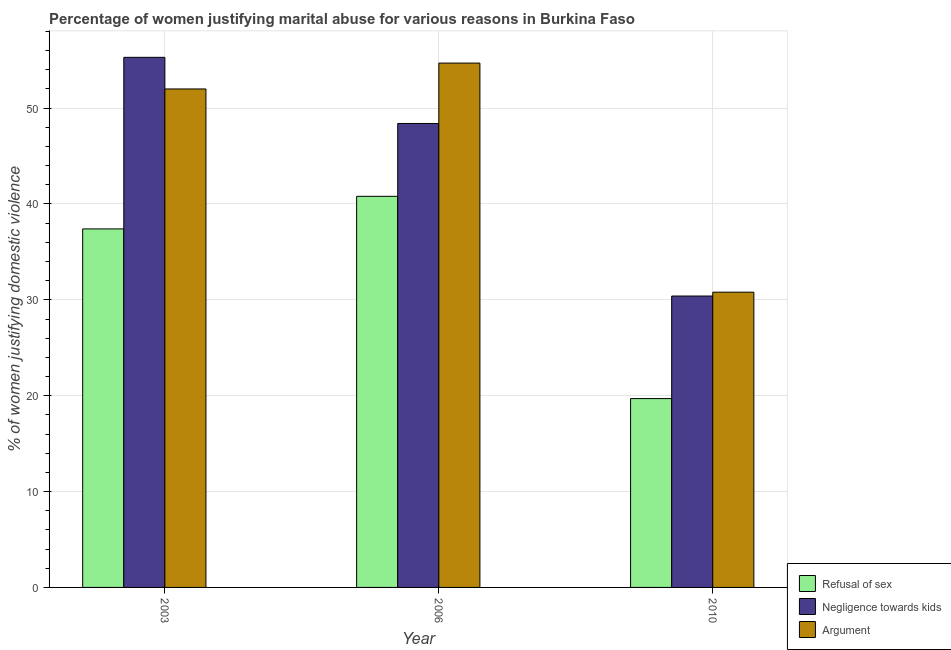How many different coloured bars are there?
Your response must be concise. 3. How many groups of bars are there?
Give a very brief answer. 3. What is the label of the 2nd group of bars from the left?
Make the answer very short. 2006. In how many cases, is the number of bars for a given year not equal to the number of legend labels?
Offer a terse response. 0. What is the percentage of women justifying domestic violence due to negligence towards kids in 2003?
Offer a terse response. 55.3. Across all years, what is the maximum percentage of women justifying domestic violence due to negligence towards kids?
Provide a short and direct response. 55.3. Across all years, what is the minimum percentage of women justifying domestic violence due to arguments?
Provide a short and direct response. 30.8. In which year was the percentage of women justifying domestic violence due to refusal of sex minimum?
Offer a very short reply. 2010. What is the total percentage of women justifying domestic violence due to arguments in the graph?
Offer a very short reply. 137.5. What is the difference between the percentage of women justifying domestic violence due to refusal of sex in 2010 and the percentage of women justifying domestic violence due to negligence towards kids in 2006?
Offer a very short reply. -21.1. What is the average percentage of women justifying domestic violence due to negligence towards kids per year?
Give a very brief answer. 44.7. In the year 2010, what is the difference between the percentage of women justifying domestic violence due to arguments and percentage of women justifying domestic violence due to negligence towards kids?
Ensure brevity in your answer.  0. In how many years, is the percentage of women justifying domestic violence due to negligence towards kids greater than 54 %?
Your answer should be compact. 1. What is the ratio of the percentage of women justifying domestic violence due to arguments in 2003 to that in 2006?
Your response must be concise. 0.95. Is the percentage of women justifying domestic violence due to arguments in 2003 less than that in 2006?
Offer a very short reply. Yes. Is the difference between the percentage of women justifying domestic violence due to arguments in 2003 and 2006 greater than the difference between the percentage of women justifying domestic violence due to refusal of sex in 2003 and 2006?
Give a very brief answer. No. What is the difference between the highest and the second highest percentage of women justifying domestic violence due to arguments?
Keep it short and to the point. 2.7. What is the difference between the highest and the lowest percentage of women justifying domestic violence due to refusal of sex?
Give a very brief answer. 21.1. What does the 2nd bar from the left in 2010 represents?
Offer a very short reply. Negligence towards kids. What does the 2nd bar from the right in 2010 represents?
Give a very brief answer. Negligence towards kids. Is it the case that in every year, the sum of the percentage of women justifying domestic violence due to refusal of sex and percentage of women justifying domestic violence due to negligence towards kids is greater than the percentage of women justifying domestic violence due to arguments?
Provide a short and direct response. Yes. How many bars are there?
Your answer should be very brief. 9. How many years are there in the graph?
Your response must be concise. 3. What is the difference between two consecutive major ticks on the Y-axis?
Keep it short and to the point. 10. How many legend labels are there?
Offer a terse response. 3. How are the legend labels stacked?
Keep it short and to the point. Vertical. What is the title of the graph?
Ensure brevity in your answer.  Percentage of women justifying marital abuse for various reasons in Burkina Faso. Does "Social Protection and Labor" appear as one of the legend labels in the graph?
Provide a short and direct response. No. What is the label or title of the X-axis?
Your response must be concise. Year. What is the label or title of the Y-axis?
Your answer should be very brief. % of women justifying domestic violence. What is the % of women justifying domestic violence of Refusal of sex in 2003?
Your response must be concise. 37.4. What is the % of women justifying domestic violence of Negligence towards kids in 2003?
Provide a succinct answer. 55.3. What is the % of women justifying domestic violence of Refusal of sex in 2006?
Make the answer very short. 40.8. What is the % of women justifying domestic violence of Negligence towards kids in 2006?
Provide a short and direct response. 48.4. What is the % of women justifying domestic violence of Argument in 2006?
Provide a short and direct response. 54.7. What is the % of women justifying domestic violence in Negligence towards kids in 2010?
Your answer should be compact. 30.4. What is the % of women justifying domestic violence of Argument in 2010?
Your response must be concise. 30.8. Across all years, what is the maximum % of women justifying domestic violence of Refusal of sex?
Your answer should be very brief. 40.8. Across all years, what is the maximum % of women justifying domestic violence in Negligence towards kids?
Keep it short and to the point. 55.3. Across all years, what is the maximum % of women justifying domestic violence of Argument?
Your response must be concise. 54.7. Across all years, what is the minimum % of women justifying domestic violence of Refusal of sex?
Offer a very short reply. 19.7. Across all years, what is the minimum % of women justifying domestic violence in Negligence towards kids?
Provide a succinct answer. 30.4. Across all years, what is the minimum % of women justifying domestic violence in Argument?
Offer a very short reply. 30.8. What is the total % of women justifying domestic violence in Refusal of sex in the graph?
Make the answer very short. 97.9. What is the total % of women justifying domestic violence in Negligence towards kids in the graph?
Provide a short and direct response. 134.1. What is the total % of women justifying domestic violence in Argument in the graph?
Your answer should be very brief. 137.5. What is the difference between the % of women justifying domestic violence in Argument in 2003 and that in 2006?
Provide a short and direct response. -2.7. What is the difference between the % of women justifying domestic violence in Negligence towards kids in 2003 and that in 2010?
Make the answer very short. 24.9. What is the difference between the % of women justifying domestic violence of Argument in 2003 and that in 2010?
Your answer should be compact. 21.2. What is the difference between the % of women justifying domestic violence of Refusal of sex in 2006 and that in 2010?
Your response must be concise. 21.1. What is the difference between the % of women justifying domestic violence of Argument in 2006 and that in 2010?
Make the answer very short. 23.9. What is the difference between the % of women justifying domestic violence in Refusal of sex in 2003 and the % of women justifying domestic violence in Argument in 2006?
Your answer should be compact. -17.3. What is the difference between the % of women justifying domestic violence of Negligence towards kids in 2003 and the % of women justifying domestic violence of Argument in 2006?
Keep it short and to the point. 0.6. What is the difference between the % of women justifying domestic violence in Refusal of sex in 2006 and the % of women justifying domestic violence in Argument in 2010?
Make the answer very short. 10. What is the average % of women justifying domestic violence of Refusal of sex per year?
Provide a short and direct response. 32.63. What is the average % of women justifying domestic violence in Negligence towards kids per year?
Your answer should be compact. 44.7. What is the average % of women justifying domestic violence in Argument per year?
Offer a terse response. 45.83. In the year 2003, what is the difference between the % of women justifying domestic violence of Refusal of sex and % of women justifying domestic violence of Negligence towards kids?
Provide a succinct answer. -17.9. In the year 2003, what is the difference between the % of women justifying domestic violence in Refusal of sex and % of women justifying domestic violence in Argument?
Offer a very short reply. -14.6. In the year 2006, what is the difference between the % of women justifying domestic violence in Refusal of sex and % of women justifying domestic violence in Argument?
Offer a very short reply. -13.9. In the year 2006, what is the difference between the % of women justifying domestic violence in Negligence towards kids and % of women justifying domestic violence in Argument?
Your answer should be compact. -6.3. In the year 2010, what is the difference between the % of women justifying domestic violence of Negligence towards kids and % of women justifying domestic violence of Argument?
Your answer should be compact. -0.4. What is the ratio of the % of women justifying domestic violence of Negligence towards kids in 2003 to that in 2006?
Provide a short and direct response. 1.14. What is the ratio of the % of women justifying domestic violence in Argument in 2003 to that in 2006?
Your response must be concise. 0.95. What is the ratio of the % of women justifying domestic violence of Refusal of sex in 2003 to that in 2010?
Your answer should be very brief. 1.9. What is the ratio of the % of women justifying domestic violence in Negligence towards kids in 2003 to that in 2010?
Offer a terse response. 1.82. What is the ratio of the % of women justifying domestic violence of Argument in 2003 to that in 2010?
Your answer should be compact. 1.69. What is the ratio of the % of women justifying domestic violence of Refusal of sex in 2006 to that in 2010?
Provide a succinct answer. 2.07. What is the ratio of the % of women justifying domestic violence of Negligence towards kids in 2006 to that in 2010?
Your answer should be compact. 1.59. What is the ratio of the % of women justifying domestic violence of Argument in 2006 to that in 2010?
Your response must be concise. 1.78. What is the difference between the highest and the second highest % of women justifying domestic violence in Negligence towards kids?
Your answer should be compact. 6.9. What is the difference between the highest and the second highest % of women justifying domestic violence of Argument?
Ensure brevity in your answer.  2.7. What is the difference between the highest and the lowest % of women justifying domestic violence of Refusal of sex?
Provide a short and direct response. 21.1. What is the difference between the highest and the lowest % of women justifying domestic violence of Negligence towards kids?
Your response must be concise. 24.9. What is the difference between the highest and the lowest % of women justifying domestic violence in Argument?
Provide a succinct answer. 23.9. 